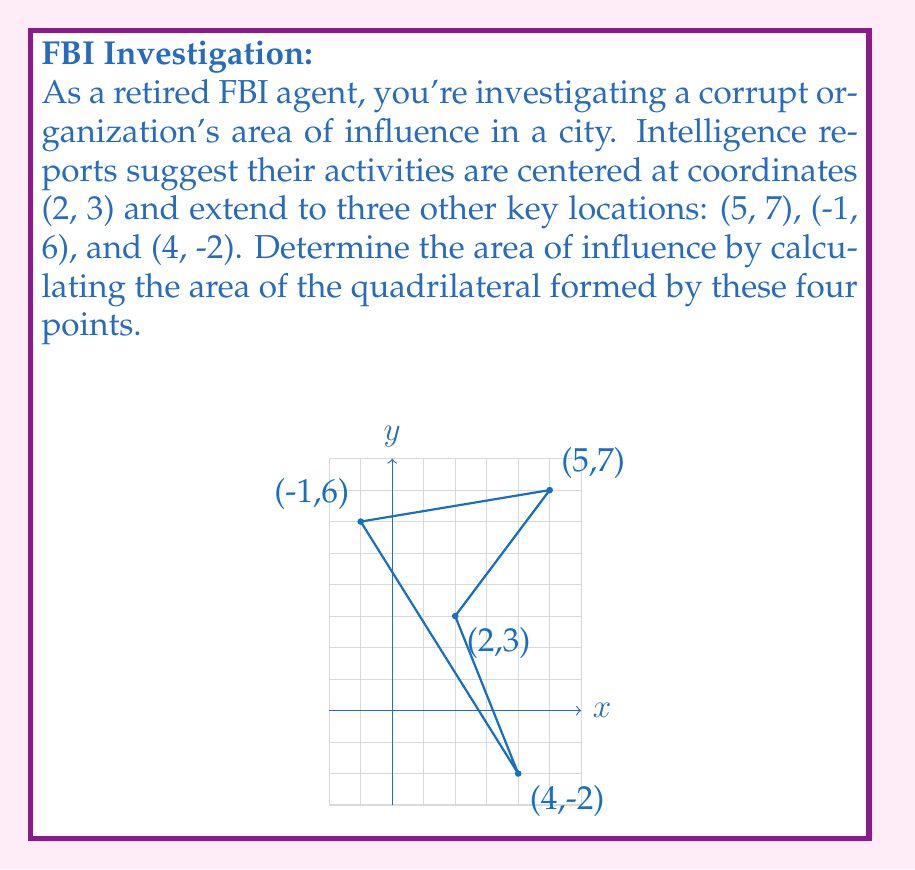Give your solution to this math problem. To solve this problem, we'll use the Shoelace formula (also known as the surveyor's formula) to calculate the area of the quadrilateral. The steps are as follows:

1) List the coordinates in order (clockwise or counterclockwise): 
   $(x_1, y_1) = (2, 3)$
   $(x_2, y_2) = (5, 7)$
   $(x_3, y_3) = (-1, 6)$
   $(x_4, y_4) = (4, -2)$

2) Apply the Shoelace formula:
   $$A = \frac{1}{2}|(x_1y_2 + x_2y_3 + x_3y_4 + x_4y_1) - (y_1x_2 + y_2x_3 + y_3x_4 + y_4x_1)|$$

3) Substitute the values:
   $$A = \frac{1}{2}|(2 \cdot 7 + 5 \cdot 6 + (-1) \cdot (-2) + 4 \cdot 3) - (3 \cdot 5 + 7 \cdot (-1) + 6 \cdot 4 + (-2) \cdot 2)|$$

4) Calculate:
   $$A = \frac{1}{2}|(14 + 30 + 2 + 12) - (15 - 7 + 24 - 4)|$$
   $$A = \frac{1}{2}|58 - 28|$$
   $$A = \frac{1}{2} \cdot 30$$
   $$A = 15$$

Therefore, the area of influence of the corrupt organization is 15 square units.
Answer: 15 square units 